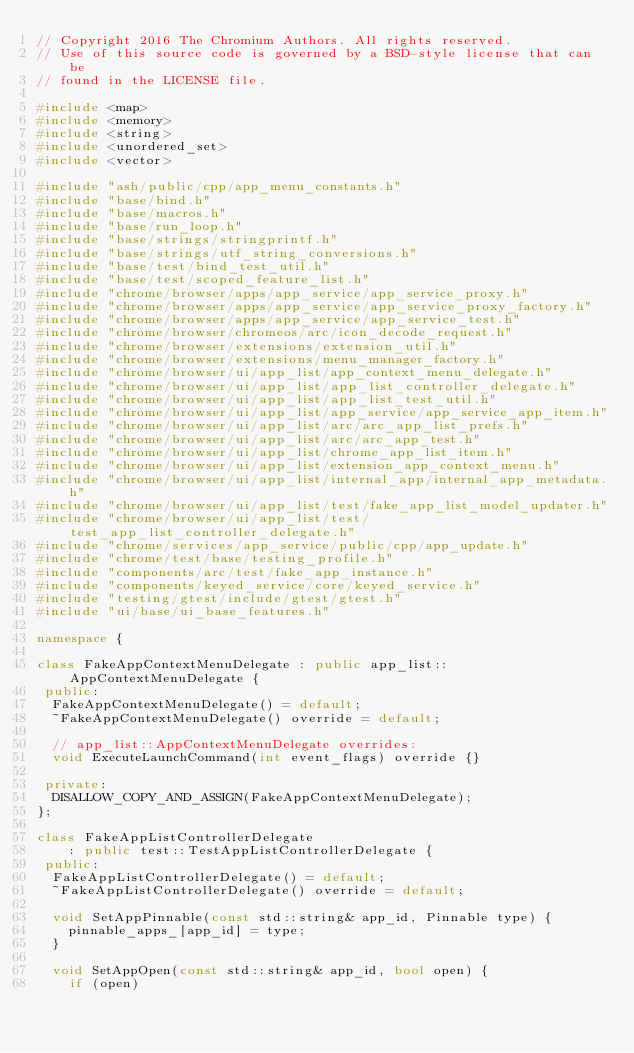<code> <loc_0><loc_0><loc_500><loc_500><_C++_>// Copyright 2016 The Chromium Authors. All rights reserved.
// Use of this source code is governed by a BSD-style license that can be
// found in the LICENSE file.

#include <map>
#include <memory>
#include <string>
#include <unordered_set>
#include <vector>

#include "ash/public/cpp/app_menu_constants.h"
#include "base/bind.h"
#include "base/macros.h"
#include "base/run_loop.h"
#include "base/strings/stringprintf.h"
#include "base/strings/utf_string_conversions.h"
#include "base/test/bind_test_util.h"
#include "base/test/scoped_feature_list.h"
#include "chrome/browser/apps/app_service/app_service_proxy.h"
#include "chrome/browser/apps/app_service/app_service_proxy_factory.h"
#include "chrome/browser/apps/app_service/app_service_test.h"
#include "chrome/browser/chromeos/arc/icon_decode_request.h"
#include "chrome/browser/extensions/extension_util.h"
#include "chrome/browser/extensions/menu_manager_factory.h"
#include "chrome/browser/ui/app_list/app_context_menu_delegate.h"
#include "chrome/browser/ui/app_list/app_list_controller_delegate.h"
#include "chrome/browser/ui/app_list/app_list_test_util.h"
#include "chrome/browser/ui/app_list/app_service/app_service_app_item.h"
#include "chrome/browser/ui/app_list/arc/arc_app_list_prefs.h"
#include "chrome/browser/ui/app_list/arc/arc_app_test.h"
#include "chrome/browser/ui/app_list/chrome_app_list_item.h"
#include "chrome/browser/ui/app_list/extension_app_context_menu.h"
#include "chrome/browser/ui/app_list/internal_app/internal_app_metadata.h"
#include "chrome/browser/ui/app_list/test/fake_app_list_model_updater.h"
#include "chrome/browser/ui/app_list/test/test_app_list_controller_delegate.h"
#include "chrome/services/app_service/public/cpp/app_update.h"
#include "chrome/test/base/testing_profile.h"
#include "components/arc/test/fake_app_instance.h"
#include "components/keyed_service/core/keyed_service.h"
#include "testing/gtest/include/gtest/gtest.h"
#include "ui/base/ui_base_features.h"

namespace {

class FakeAppContextMenuDelegate : public app_list::AppContextMenuDelegate {
 public:
  FakeAppContextMenuDelegate() = default;
  ~FakeAppContextMenuDelegate() override = default;

  // app_list::AppContextMenuDelegate overrides:
  void ExecuteLaunchCommand(int event_flags) override {}

 private:
  DISALLOW_COPY_AND_ASSIGN(FakeAppContextMenuDelegate);
};

class FakeAppListControllerDelegate
    : public test::TestAppListControllerDelegate {
 public:
  FakeAppListControllerDelegate() = default;
  ~FakeAppListControllerDelegate() override = default;

  void SetAppPinnable(const std::string& app_id, Pinnable type) {
    pinnable_apps_[app_id] = type;
  }

  void SetAppOpen(const std::string& app_id, bool open) {
    if (open)</code> 